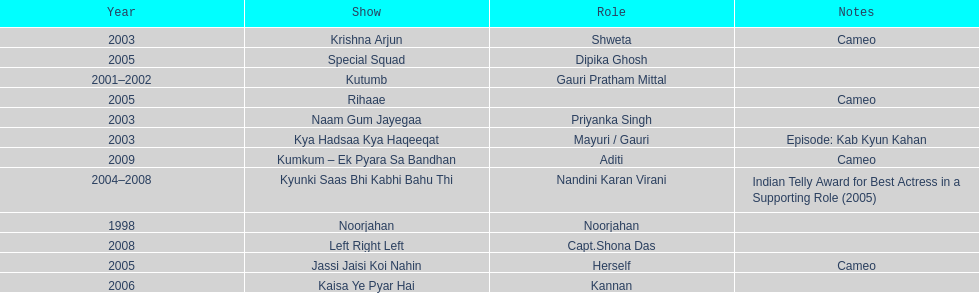What was the most years a show lasted? 4. 